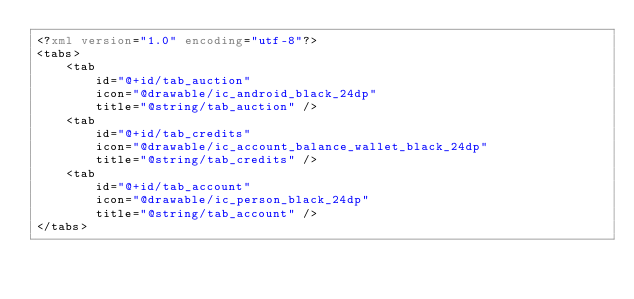<code> <loc_0><loc_0><loc_500><loc_500><_XML_><?xml version="1.0" encoding="utf-8"?>
<tabs>
    <tab
        id="@+id/tab_auction"
        icon="@drawable/ic_android_black_24dp"
        title="@string/tab_auction" />
    <tab
        id="@+id/tab_credits"
        icon="@drawable/ic_account_balance_wallet_black_24dp"
        title="@string/tab_credits" />
    <tab
        id="@+id/tab_account"
        icon="@drawable/ic_person_black_24dp"
        title="@string/tab_account" />
</tabs></code> 